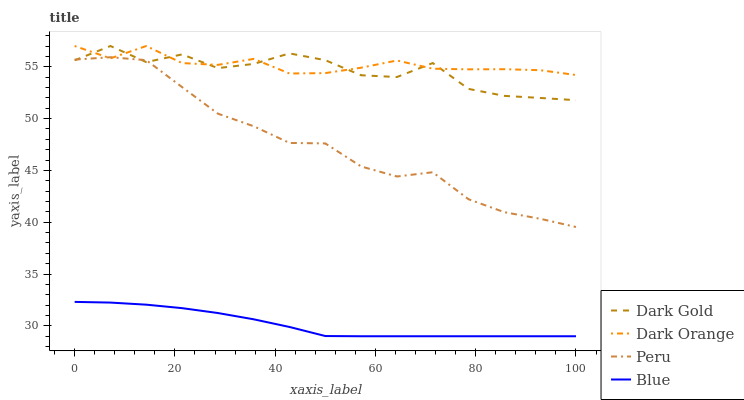Does Blue have the minimum area under the curve?
Answer yes or no. Yes. Does Dark Orange have the maximum area under the curve?
Answer yes or no. Yes. Does Peru have the minimum area under the curve?
Answer yes or no. No. Does Peru have the maximum area under the curve?
Answer yes or no. No. Is Blue the smoothest?
Answer yes or no. Yes. Is Dark Gold the roughest?
Answer yes or no. Yes. Is Dark Orange the smoothest?
Answer yes or no. No. Is Dark Orange the roughest?
Answer yes or no. No. Does Peru have the lowest value?
Answer yes or no. No. Does Dark Gold have the highest value?
Answer yes or no. Yes. Does Peru have the highest value?
Answer yes or no. No. Is Blue less than Dark Orange?
Answer yes or no. Yes. Is Peru greater than Blue?
Answer yes or no. Yes. Does Peru intersect Dark Orange?
Answer yes or no. Yes. Is Peru less than Dark Orange?
Answer yes or no. No. Is Peru greater than Dark Orange?
Answer yes or no. No. Does Blue intersect Dark Orange?
Answer yes or no. No. 